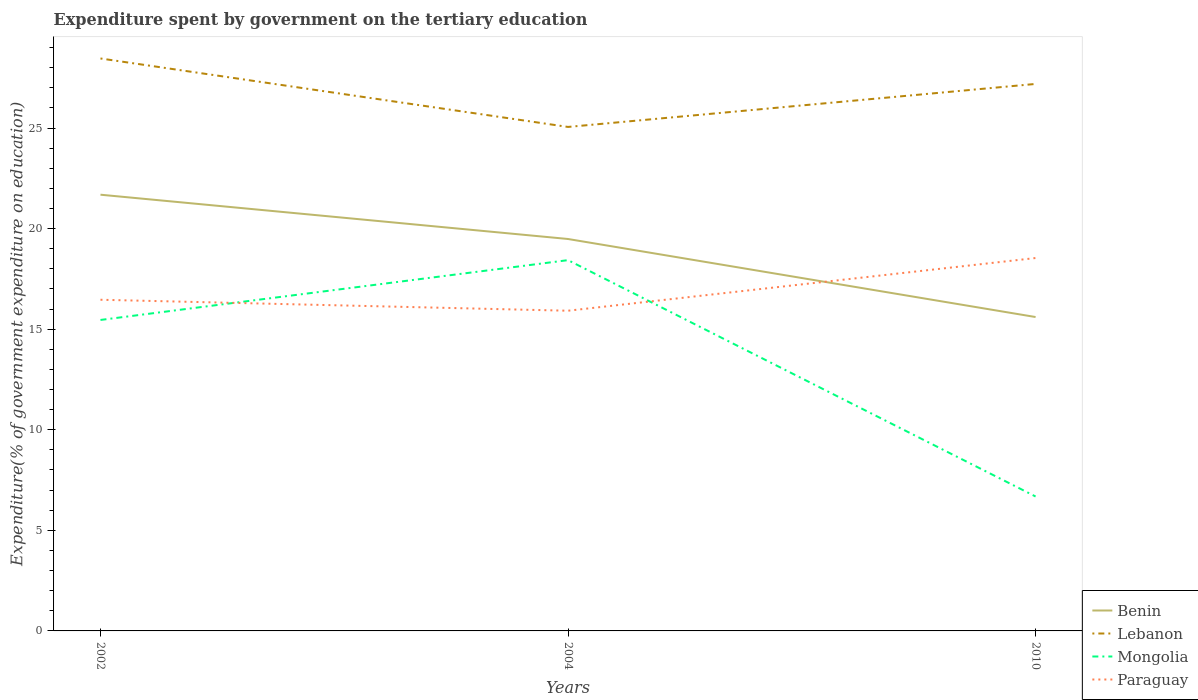How many different coloured lines are there?
Your answer should be compact. 4. Does the line corresponding to Paraguay intersect with the line corresponding to Mongolia?
Ensure brevity in your answer.  Yes. Across all years, what is the maximum expenditure spent by government on the tertiary education in Mongolia?
Your response must be concise. 6.68. In which year was the expenditure spent by government on the tertiary education in Mongolia maximum?
Ensure brevity in your answer.  2010. What is the total expenditure spent by government on the tertiary education in Mongolia in the graph?
Your answer should be compact. -2.97. What is the difference between the highest and the second highest expenditure spent by government on the tertiary education in Benin?
Your answer should be very brief. 6.08. What is the difference between the highest and the lowest expenditure spent by government on the tertiary education in Mongolia?
Offer a very short reply. 2. Is the expenditure spent by government on the tertiary education in Mongolia strictly greater than the expenditure spent by government on the tertiary education in Benin over the years?
Provide a short and direct response. Yes. How many lines are there?
Make the answer very short. 4. How many years are there in the graph?
Keep it short and to the point. 3. Are the values on the major ticks of Y-axis written in scientific E-notation?
Keep it short and to the point. No. Does the graph contain any zero values?
Keep it short and to the point. No. Does the graph contain grids?
Keep it short and to the point. No. Where does the legend appear in the graph?
Provide a short and direct response. Bottom right. How many legend labels are there?
Offer a terse response. 4. How are the legend labels stacked?
Offer a very short reply. Vertical. What is the title of the graph?
Your answer should be very brief. Expenditure spent by government on the tertiary education. Does "Benin" appear as one of the legend labels in the graph?
Your answer should be compact. Yes. What is the label or title of the X-axis?
Offer a terse response. Years. What is the label or title of the Y-axis?
Your response must be concise. Expenditure(% of government expenditure on education). What is the Expenditure(% of government expenditure on education) of Benin in 2002?
Your answer should be very brief. 21.69. What is the Expenditure(% of government expenditure on education) of Lebanon in 2002?
Keep it short and to the point. 28.46. What is the Expenditure(% of government expenditure on education) in Mongolia in 2002?
Offer a very short reply. 15.46. What is the Expenditure(% of government expenditure on education) of Paraguay in 2002?
Provide a succinct answer. 16.46. What is the Expenditure(% of government expenditure on education) in Benin in 2004?
Your response must be concise. 19.48. What is the Expenditure(% of government expenditure on education) in Lebanon in 2004?
Give a very brief answer. 25.05. What is the Expenditure(% of government expenditure on education) of Mongolia in 2004?
Provide a short and direct response. 18.43. What is the Expenditure(% of government expenditure on education) in Paraguay in 2004?
Offer a terse response. 15.92. What is the Expenditure(% of government expenditure on education) of Benin in 2010?
Give a very brief answer. 15.6. What is the Expenditure(% of government expenditure on education) in Lebanon in 2010?
Keep it short and to the point. 27.19. What is the Expenditure(% of government expenditure on education) of Mongolia in 2010?
Make the answer very short. 6.68. What is the Expenditure(% of government expenditure on education) of Paraguay in 2010?
Offer a terse response. 18.54. Across all years, what is the maximum Expenditure(% of government expenditure on education) of Benin?
Ensure brevity in your answer.  21.69. Across all years, what is the maximum Expenditure(% of government expenditure on education) in Lebanon?
Your answer should be compact. 28.46. Across all years, what is the maximum Expenditure(% of government expenditure on education) in Mongolia?
Provide a succinct answer. 18.43. Across all years, what is the maximum Expenditure(% of government expenditure on education) of Paraguay?
Keep it short and to the point. 18.54. Across all years, what is the minimum Expenditure(% of government expenditure on education) of Benin?
Your response must be concise. 15.6. Across all years, what is the minimum Expenditure(% of government expenditure on education) of Lebanon?
Give a very brief answer. 25.05. Across all years, what is the minimum Expenditure(% of government expenditure on education) in Mongolia?
Provide a succinct answer. 6.68. Across all years, what is the minimum Expenditure(% of government expenditure on education) in Paraguay?
Offer a very short reply. 15.92. What is the total Expenditure(% of government expenditure on education) in Benin in the graph?
Your answer should be very brief. 56.77. What is the total Expenditure(% of government expenditure on education) of Lebanon in the graph?
Keep it short and to the point. 80.7. What is the total Expenditure(% of government expenditure on education) of Mongolia in the graph?
Make the answer very short. 40.57. What is the total Expenditure(% of government expenditure on education) in Paraguay in the graph?
Ensure brevity in your answer.  50.92. What is the difference between the Expenditure(% of government expenditure on education) of Benin in 2002 and that in 2004?
Keep it short and to the point. 2.2. What is the difference between the Expenditure(% of government expenditure on education) of Lebanon in 2002 and that in 2004?
Your answer should be very brief. 3.4. What is the difference between the Expenditure(% of government expenditure on education) of Mongolia in 2002 and that in 2004?
Give a very brief answer. -2.97. What is the difference between the Expenditure(% of government expenditure on education) of Paraguay in 2002 and that in 2004?
Make the answer very short. 0.55. What is the difference between the Expenditure(% of government expenditure on education) in Benin in 2002 and that in 2010?
Ensure brevity in your answer.  6.08. What is the difference between the Expenditure(% of government expenditure on education) in Lebanon in 2002 and that in 2010?
Offer a very short reply. 1.27. What is the difference between the Expenditure(% of government expenditure on education) in Mongolia in 2002 and that in 2010?
Provide a succinct answer. 8.78. What is the difference between the Expenditure(% of government expenditure on education) in Paraguay in 2002 and that in 2010?
Offer a terse response. -2.08. What is the difference between the Expenditure(% of government expenditure on education) of Benin in 2004 and that in 2010?
Your answer should be very brief. 3.88. What is the difference between the Expenditure(% of government expenditure on education) of Lebanon in 2004 and that in 2010?
Offer a very short reply. -2.14. What is the difference between the Expenditure(% of government expenditure on education) of Mongolia in 2004 and that in 2010?
Make the answer very short. 11.75. What is the difference between the Expenditure(% of government expenditure on education) of Paraguay in 2004 and that in 2010?
Ensure brevity in your answer.  -2.62. What is the difference between the Expenditure(% of government expenditure on education) in Benin in 2002 and the Expenditure(% of government expenditure on education) in Lebanon in 2004?
Ensure brevity in your answer.  -3.37. What is the difference between the Expenditure(% of government expenditure on education) of Benin in 2002 and the Expenditure(% of government expenditure on education) of Mongolia in 2004?
Make the answer very short. 3.25. What is the difference between the Expenditure(% of government expenditure on education) in Benin in 2002 and the Expenditure(% of government expenditure on education) in Paraguay in 2004?
Make the answer very short. 5.77. What is the difference between the Expenditure(% of government expenditure on education) of Lebanon in 2002 and the Expenditure(% of government expenditure on education) of Mongolia in 2004?
Your response must be concise. 10.03. What is the difference between the Expenditure(% of government expenditure on education) in Lebanon in 2002 and the Expenditure(% of government expenditure on education) in Paraguay in 2004?
Your response must be concise. 12.54. What is the difference between the Expenditure(% of government expenditure on education) of Mongolia in 2002 and the Expenditure(% of government expenditure on education) of Paraguay in 2004?
Ensure brevity in your answer.  -0.46. What is the difference between the Expenditure(% of government expenditure on education) of Benin in 2002 and the Expenditure(% of government expenditure on education) of Lebanon in 2010?
Your response must be concise. -5.51. What is the difference between the Expenditure(% of government expenditure on education) of Benin in 2002 and the Expenditure(% of government expenditure on education) of Mongolia in 2010?
Your answer should be very brief. 15. What is the difference between the Expenditure(% of government expenditure on education) in Benin in 2002 and the Expenditure(% of government expenditure on education) in Paraguay in 2010?
Provide a succinct answer. 3.15. What is the difference between the Expenditure(% of government expenditure on education) of Lebanon in 2002 and the Expenditure(% of government expenditure on education) of Mongolia in 2010?
Your answer should be very brief. 21.78. What is the difference between the Expenditure(% of government expenditure on education) of Lebanon in 2002 and the Expenditure(% of government expenditure on education) of Paraguay in 2010?
Provide a succinct answer. 9.92. What is the difference between the Expenditure(% of government expenditure on education) in Mongolia in 2002 and the Expenditure(% of government expenditure on education) in Paraguay in 2010?
Your response must be concise. -3.08. What is the difference between the Expenditure(% of government expenditure on education) of Benin in 2004 and the Expenditure(% of government expenditure on education) of Lebanon in 2010?
Your answer should be compact. -7.71. What is the difference between the Expenditure(% of government expenditure on education) in Benin in 2004 and the Expenditure(% of government expenditure on education) in Mongolia in 2010?
Offer a terse response. 12.8. What is the difference between the Expenditure(% of government expenditure on education) in Benin in 2004 and the Expenditure(% of government expenditure on education) in Paraguay in 2010?
Ensure brevity in your answer.  0.95. What is the difference between the Expenditure(% of government expenditure on education) of Lebanon in 2004 and the Expenditure(% of government expenditure on education) of Mongolia in 2010?
Keep it short and to the point. 18.37. What is the difference between the Expenditure(% of government expenditure on education) in Lebanon in 2004 and the Expenditure(% of government expenditure on education) in Paraguay in 2010?
Offer a terse response. 6.52. What is the difference between the Expenditure(% of government expenditure on education) of Mongolia in 2004 and the Expenditure(% of government expenditure on education) of Paraguay in 2010?
Keep it short and to the point. -0.11. What is the average Expenditure(% of government expenditure on education) in Benin per year?
Ensure brevity in your answer.  18.92. What is the average Expenditure(% of government expenditure on education) of Lebanon per year?
Make the answer very short. 26.9. What is the average Expenditure(% of government expenditure on education) in Mongolia per year?
Offer a very short reply. 13.52. What is the average Expenditure(% of government expenditure on education) in Paraguay per year?
Provide a succinct answer. 16.97. In the year 2002, what is the difference between the Expenditure(% of government expenditure on education) in Benin and Expenditure(% of government expenditure on education) in Lebanon?
Make the answer very short. -6.77. In the year 2002, what is the difference between the Expenditure(% of government expenditure on education) in Benin and Expenditure(% of government expenditure on education) in Mongolia?
Provide a succinct answer. 6.23. In the year 2002, what is the difference between the Expenditure(% of government expenditure on education) of Benin and Expenditure(% of government expenditure on education) of Paraguay?
Provide a short and direct response. 5.22. In the year 2002, what is the difference between the Expenditure(% of government expenditure on education) in Lebanon and Expenditure(% of government expenditure on education) in Mongolia?
Ensure brevity in your answer.  13. In the year 2002, what is the difference between the Expenditure(% of government expenditure on education) of Lebanon and Expenditure(% of government expenditure on education) of Paraguay?
Your answer should be compact. 11.99. In the year 2002, what is the difference between the Expenditure(% of government expenditure on education) of Mongolia and Expenditure(% of government expenditure on education) of Paraguay?
Your response must be concise. -1. In the year 2004, what is the difference between the Expenditure(% of government expenditure on education) in Benin and Expenditure(% of government expenditure on education) in Lebanon?
Ensure brevity in your answer.  -5.57. In the year 2004, what is the difference between the Expenditure(% of government expenditure on education) of Benin and Expenditure(% of government expenditure on education) of Mongolia?
Offer a terse response. 1.05. In the year 2004, what is the difference between the Expenditure(% of government expenditure on education) of Benin and Expenditure(% of government expenditure on education) of Paraguay?
Your answer should be compact. 3.57. In the year 2004, what is the difference between the Expenditure(% of government expenditure on education) in Lebanon and Expenditure(% of government expenditure on education) in Mongolia?
Provide a succinct answer. 6.62. In the year 2004, what is the difference between the Expenditure(% of government expenditure on education) in Lebanon and Expenditure(% of government expenditure on education) in Paraguay?
Provide a succinct answer. 9.14. In the year 2004, what is the difference between the Expenditure(% of government expenditure on education) in Mongolia and Expenditure(% of government expenditure on education) in Paraguay?
Offer a very short reply. 2.51. In the year 2010, what is the difference between the Expenditure(% of government expenditure on education) of Benin and Expenditure(% of government expenditure on education) of Lebanon?
Your response must be concise. -11.59. In the year 2010, what is the difference between the Expenditure(% of government expenditure on education) of Benin and Expenditure(% of government expenditure on education) of Mongolia?
Provide a short and direct response. 8.92. In the year 2010, what is the difference between the Expenditure(% of government expenditure on education) of Benin and Expenditure(% of government expenditure on education) of Paraguay?
Offer a terse response. -2.93. In the year 2010, what is the difference between the Expenditure(% of government expenditure on education) of Lebanon and Expenditure(% of government expenditure on education) of Mongolia?
Offer a terse response. 20.51. In the year 2010, what is the difference between the Expenditure(% of government expenditure on education) of Lebanon and Expenditure(% of government expenditure on education) of Paraguay?
Your answer should be compact. 8.65. In the year 2010, what is the difference between the Expenditure(% of government expenditure on education) of Mongolia and Expenditure(% of government expenditure on education) of Paraguay?
Ensure brevity in your answer.  -11.86. What is the ratio of the Expenditure(% of government expenditure on education) in Benin in 2002 to that in 2004?
Make the answer very short. 1.11. What is the ratio of the Expenditure(% of government expenditure on education) of Lebanon in 2002 to that in 2004?
Give a very brief answer. 1.14. What is the ratio of the Expenditure(% of government expenditure on education) in Mongolia in 2002 to that in 2004?
Offer a very short reply. 0.84. What is the ratio of the Expenditure(% of government expenditure on education) in Paraguay in 2002 to that in 2004?
Make the answer very short. 1.03. What is the ratio of the Expenditure(% of government expenditure on education) of Benin in 2002 to that in 2010?
Your response must be concise. 1.39. What is the ratio of the Expenditure(% of government expenditure on education) of Lebanon in 2002 to that in 2010?
Provide a succinct answer. 1.05. What is the ratio of the Expenditure(% of government expenditure on education) of Mongolia in 2002 to that in 2010?
Provide a short and direct response. 2.31. What is the ratio of the Expenditure(% of government expenditure on education) in Paraguay in 2002 to that in 2010?
Your answer should be compact. 0.89. What is the ratio of the Expenditure(% of government expenditure on education) in Benin in 2004 to that in 2010?
Offer a very short reply. 1.25. What is the ratio of the Expenditure(% of government expenditure on education) of Lebanon in 2004 to that in 2010?
Provide a succinct answer. 0.92. What is the ratio of the Expenditure(% of government expenditure on education) in Mongolia in 2004 to that in 2010?
Ensure brevity in your answer.  2.76. What is the ratio of the Expenditure(% of government expenditure on education) in Paraguay in 2004 to that in 2010?
Your response must be concise. 0.86. What is the difference between the highest and the second highest Expenditure(% of government expenditure on education) in Benin?
Provide a succinct answer. 2.2. What is the difference between the highest and the second highest Expenditure(% of government expenditure on education) of Lebanon?
Make the answer very short. 1.27. What is the difference between the highest and the second highest Expenditure(% of government expenditure on education) of Mongolia?
Your answer should be compact. 2.97. What is the difference between the highest and the second highest Expenditure(% of government expenditure on education) of Paraguay?
Ensure brevity in your answer.  2.08. What is the difference between the highest and the lowest Expenditure(% of government expenditure on education) of Benin?
Provide a succinct answer. 6.08. What is the difference between the highest and the lowest Expenditure(% of government expenditure on education) in Lebanon?
Make the answer very short. 3.4. What is the difference between the highest and the lowest Expenditure(% of government expenditure on education) of Mongolia?
Provide a short and direct response. 11.75. What is the difference between the highest and the lowest Expenditure(% of government expenditure on education) of Paraguay?
Keep it short and to the point. 2.62. 